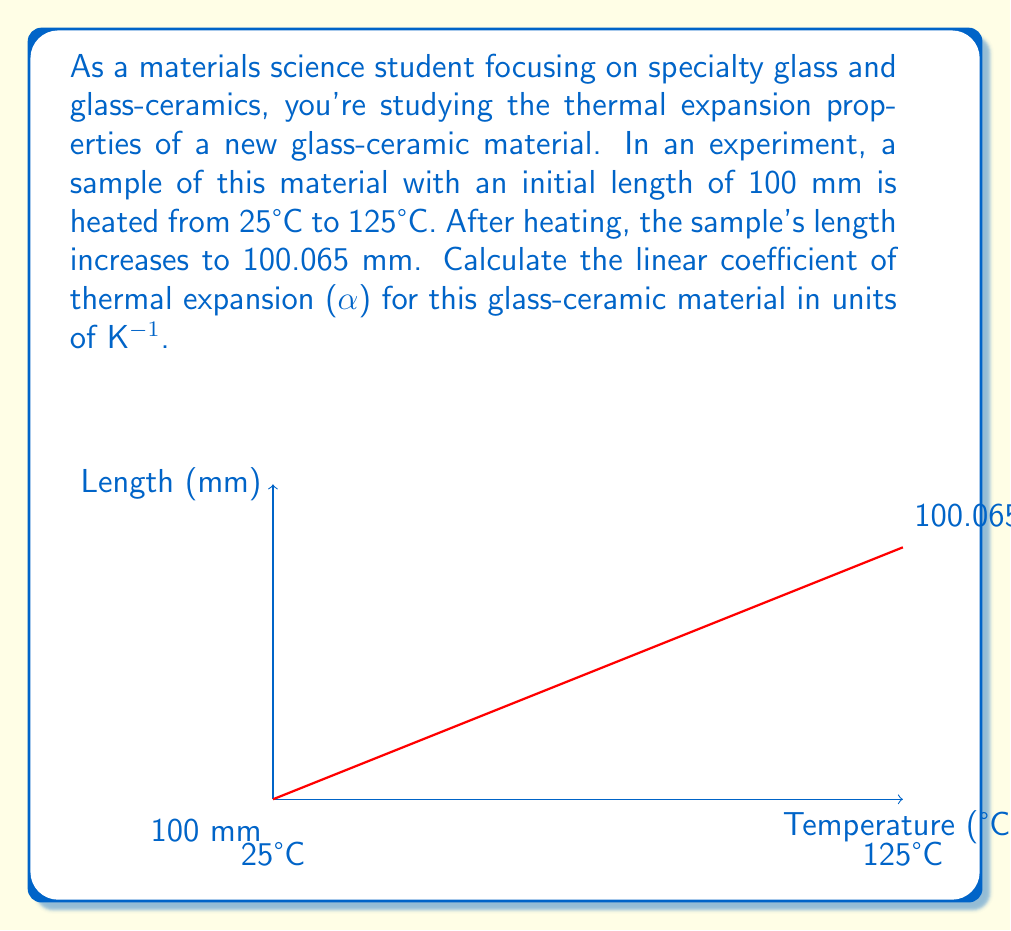Can you answer this question? Let's approach this step-by-step:

1) The linear coefficient of thermal expansion (α) is given by the formula:

   $$ \alpha = \frac{\Delta L}{L_0 \cdot \Delta T} $$

   Where:
   $\Delta L$ = change in length
   $L_0$ = initial length
   $\Delta T$ = change in temperature

2) Calculate $\Delta L$:
   $\Delta L = L_{final} - L_{initial} = 100.065 \text{ mm} - 100 \text{ mm} = 0.065 \text{ mm}$

3) Identify $L_0$:
   $L_0 = 100 \text{ mm}$

4) Calculate $\Delta T$:
   $\Delta T = T_{final} - T_{initial} = 125°C - 25°C = 100°C$
   
   Note: We need to convert this to Kelvin as α is typically expressed in K^(-1)
   $\Delta T = 100 \text{ K}$ (since 1°C = 1 K for temperature differences)

5) Now, let's substitute these values into our equation:

   $$ \alpha = \frac{0.065 \text{ mm}}{(100 \text{ mm}) \cdot (100 \text{ K})} $$

6) Simplify:
   $$ \alpha = \frac{0.065}{10000} \text{ K}^{-1} = 6.5 \times 10^{-6} \text{ K}^{-1} $$
Answer: $6.5 \times 10^{-6} \text{ K}^{-1}$ 